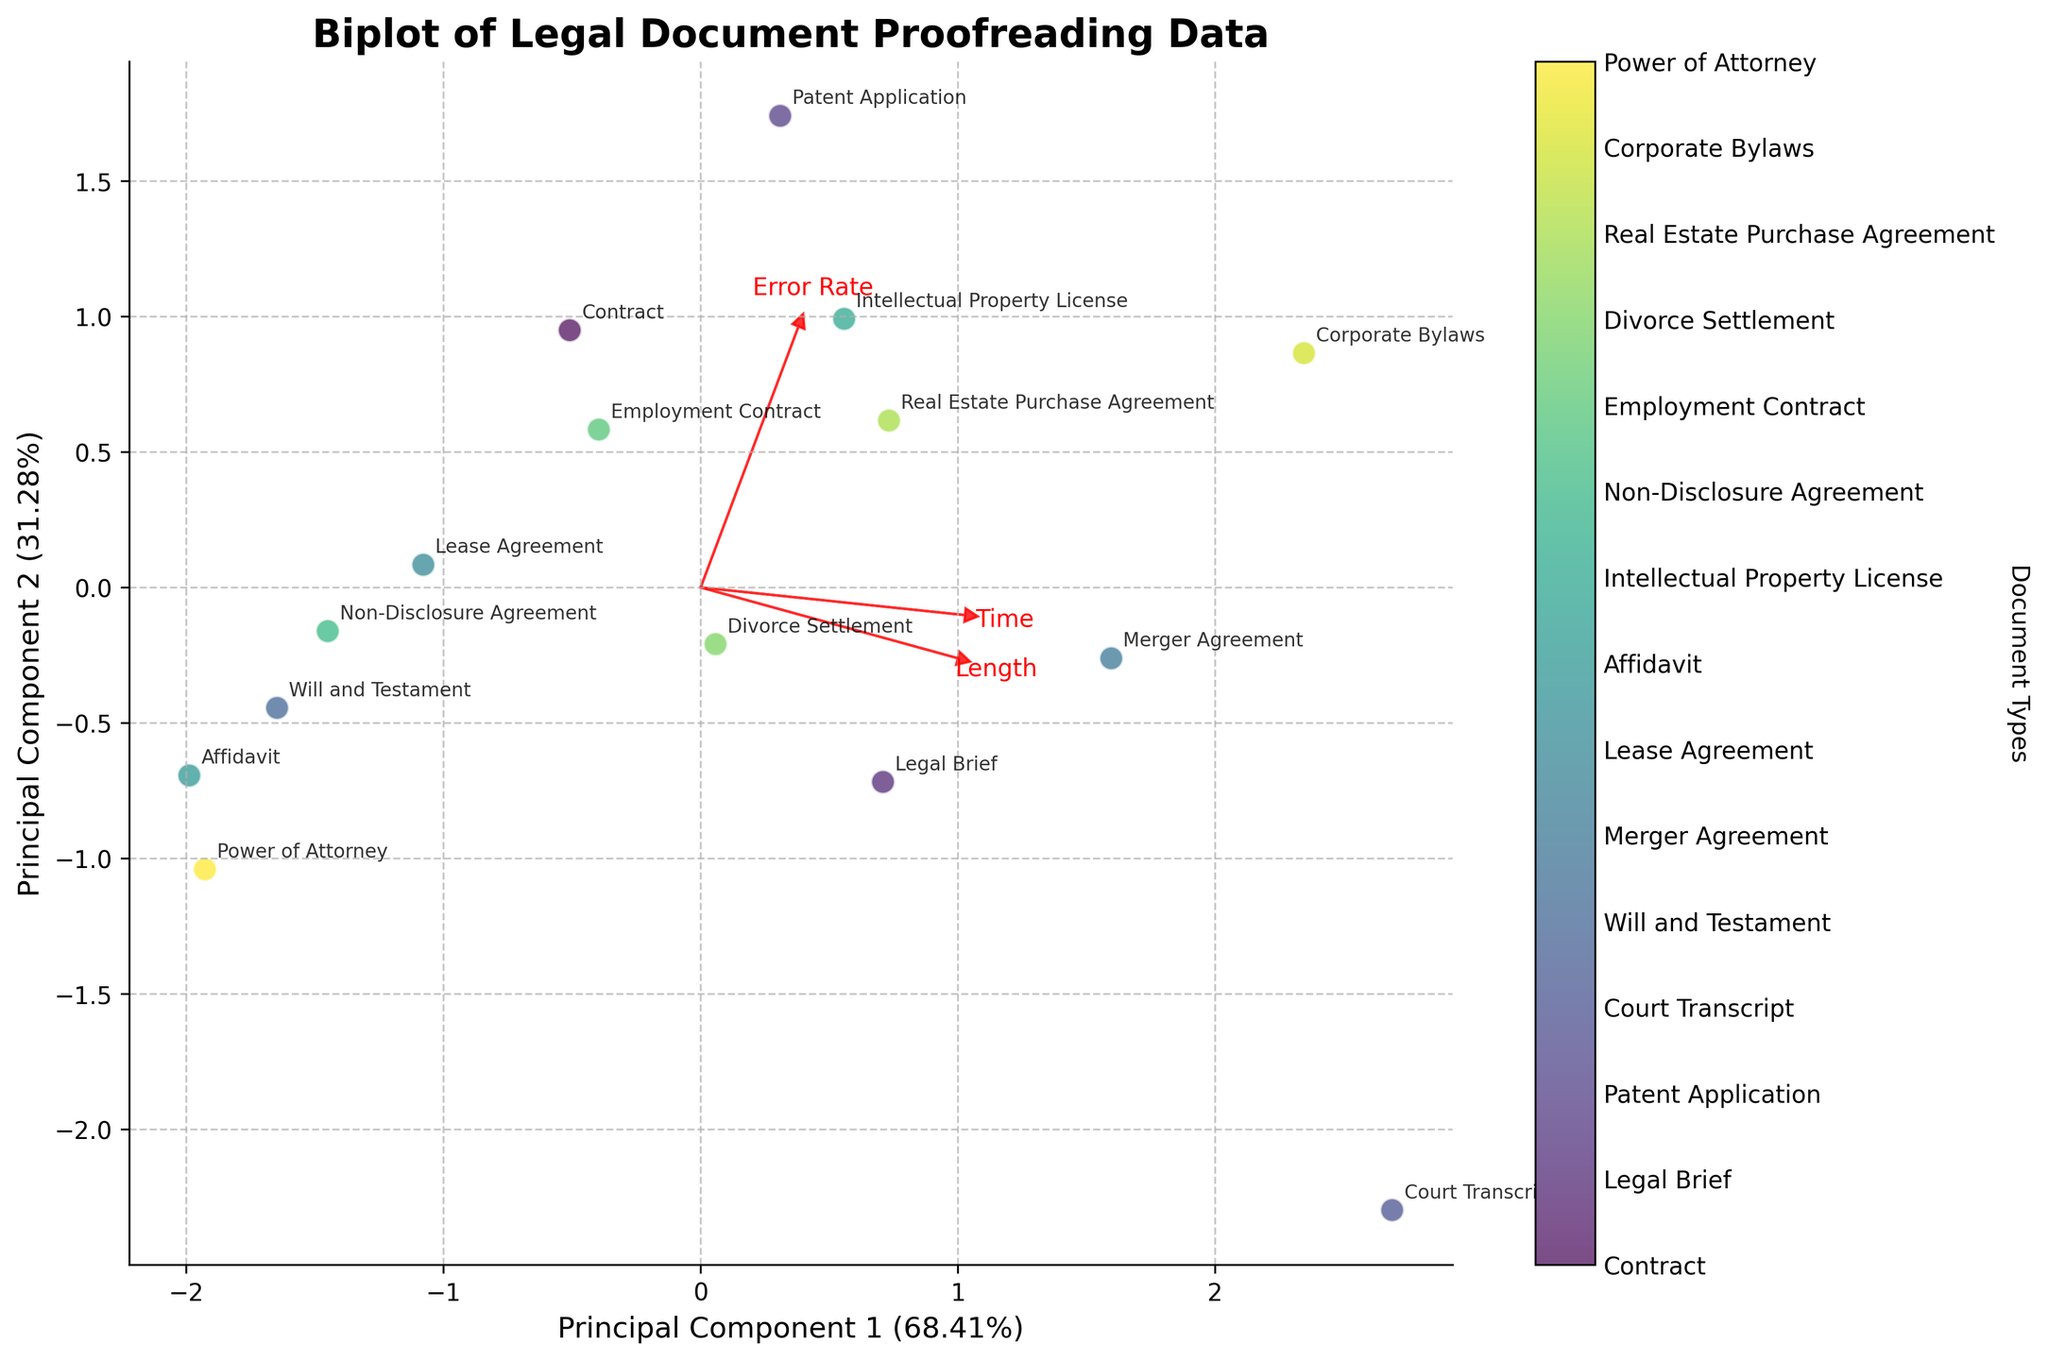What is the title of the biplot? The title of the biplot is prominently displayed at the top of the figure. Titles typically summarize the main topic or variable being investigated.
Answer: Biplot of Legal Document Proofreading Data Which two principal components are displayed on the axes? The x-axis and y-axis labels indicate the two principal components derived from the PCA analysis. The percentages in the labels represent the variance explained by each component.
Answer: Principal Component 1 and Principal Component 2 How many document types are represented in the biplot? The colorbar legend on the right side of the biplot shows different document types and their colors. By counting the unique entries, one can determine the number of document types.
Answer: 15 What is the direction of the 'Error Rate' vector in the plot? The 'Error Rate' vector's direction can be assessed by looking at the arrow labeled 'Error Rate' and noting its orientation relative to the axes.
Answer: Northeast Which document type appears closest to the 'Length' vector's endpoint? By observing the placement of document type labels and the endpoint of the 'Length' vector arrow, one can identify the document type that is positioned closest.
Answer: Court Transcript Which principal component explains more of the variance? The percentages on the x-axis and y-axis labels indicate the variance explained by each principal component. The higher percentage corresponds to the component explaining more variance.
Answer: Principal Component 1 Which document type has the highest proofreading time and is located farthest along the 'Time' vector? By examining the 'Time' vector and the placement of document type annotations, one can find the document that is farthest along this vector.
Answer: Court Transcript Which principal component seems to correlate more with 'Error Rate'? Observing the angle between the 'Error Rate' vector and the two principal components' axes, a smaller angle indicates higher correlation.
Answer: Principal Component 2 Is 'Proofreading Time' positively correlated with 'Length'? A positive correlation between 'Proofreading Time' and 'Length' is indicated by both vectors pointing in roughly the same direction. We assess the directionality and similarity.
Answer: Yes Which documents are clustered close to each other in PCA space? By analyzing the scatter plot and identifying clusters of document types located in close proximity, clustered documents can be pinpointed.
Answer: Legal Brief, Non-Disclosure Agreement, and Lease Agreement 